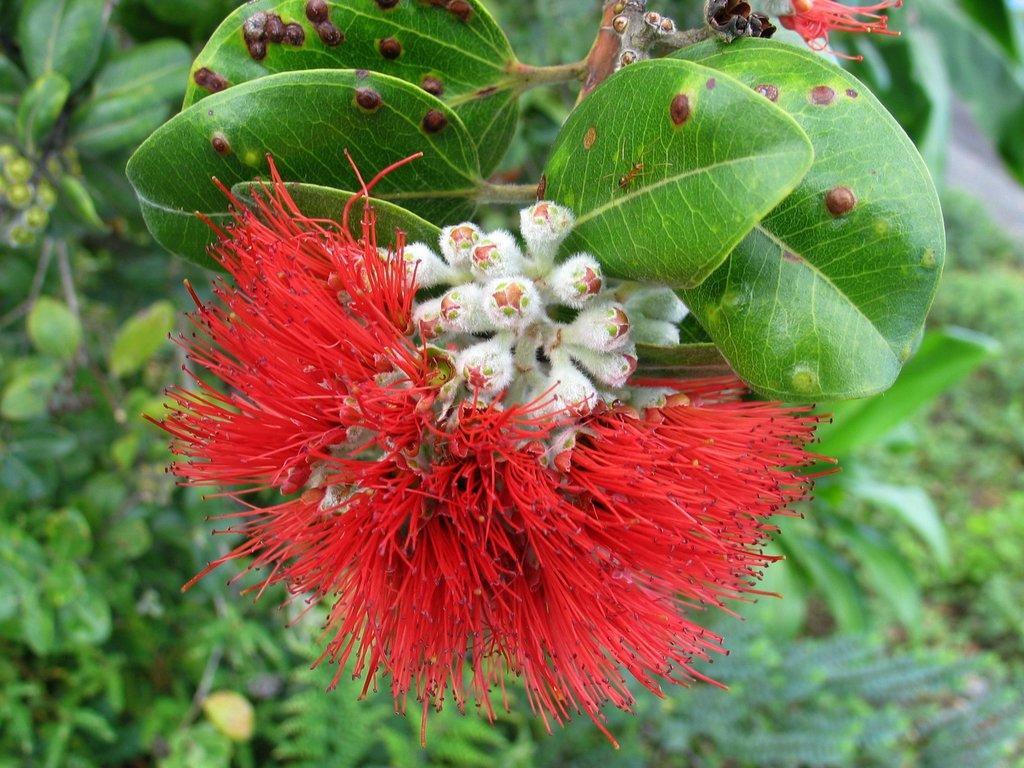Describe this image in one or two sentences. In this picture we can observe a red color flower. There are white color flower buds. We can observe a plant. In the background there are some plants. 